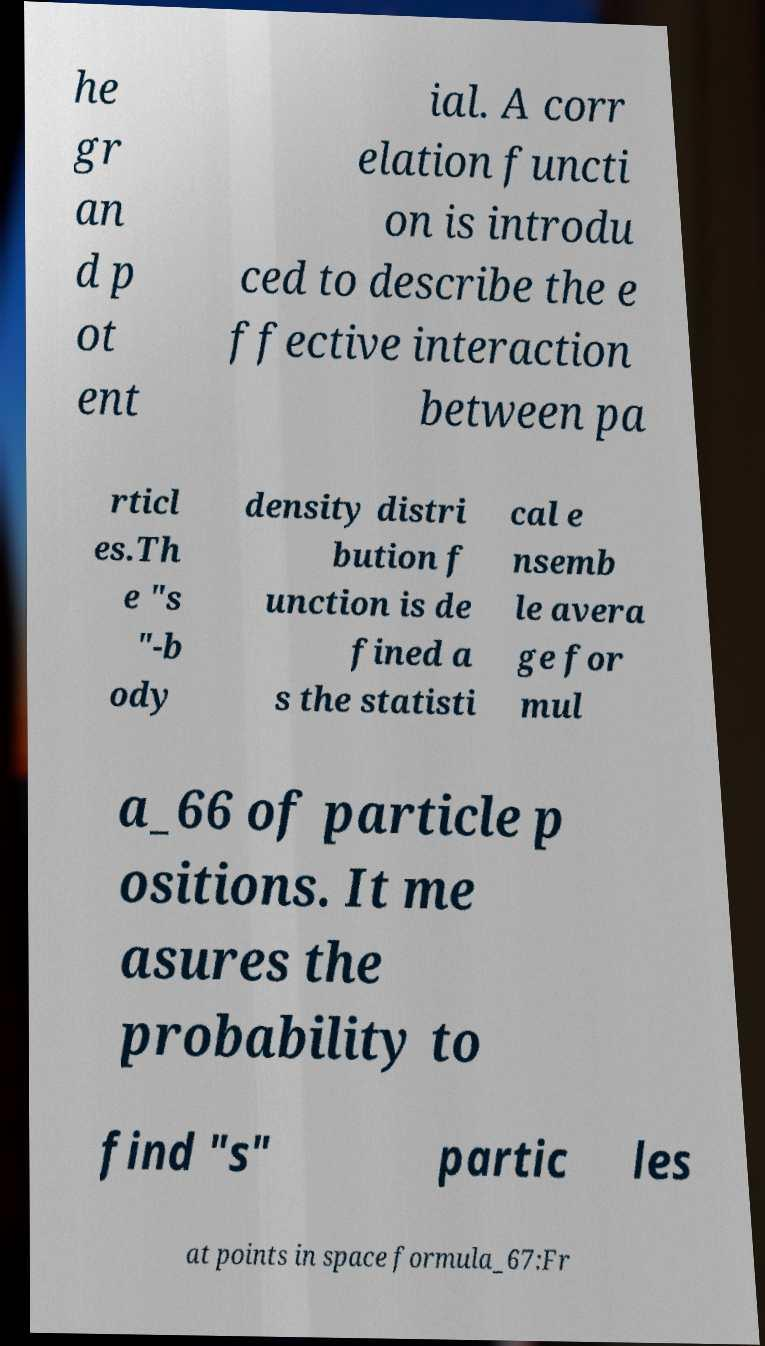Please identify and transcribe the text found in this image. he gr an d p ot ent ial. A corr elation functi on is introdu ced to describe the e ffective interaction between pa rticl es.Th e "s "-b ody density distri bution f unction is de fined a s the statisti cal e nsemb le avera ge for mul a_66 of particle p ositions. It me asures the probability to find "s" partic les at points in space formula_67:Fr 